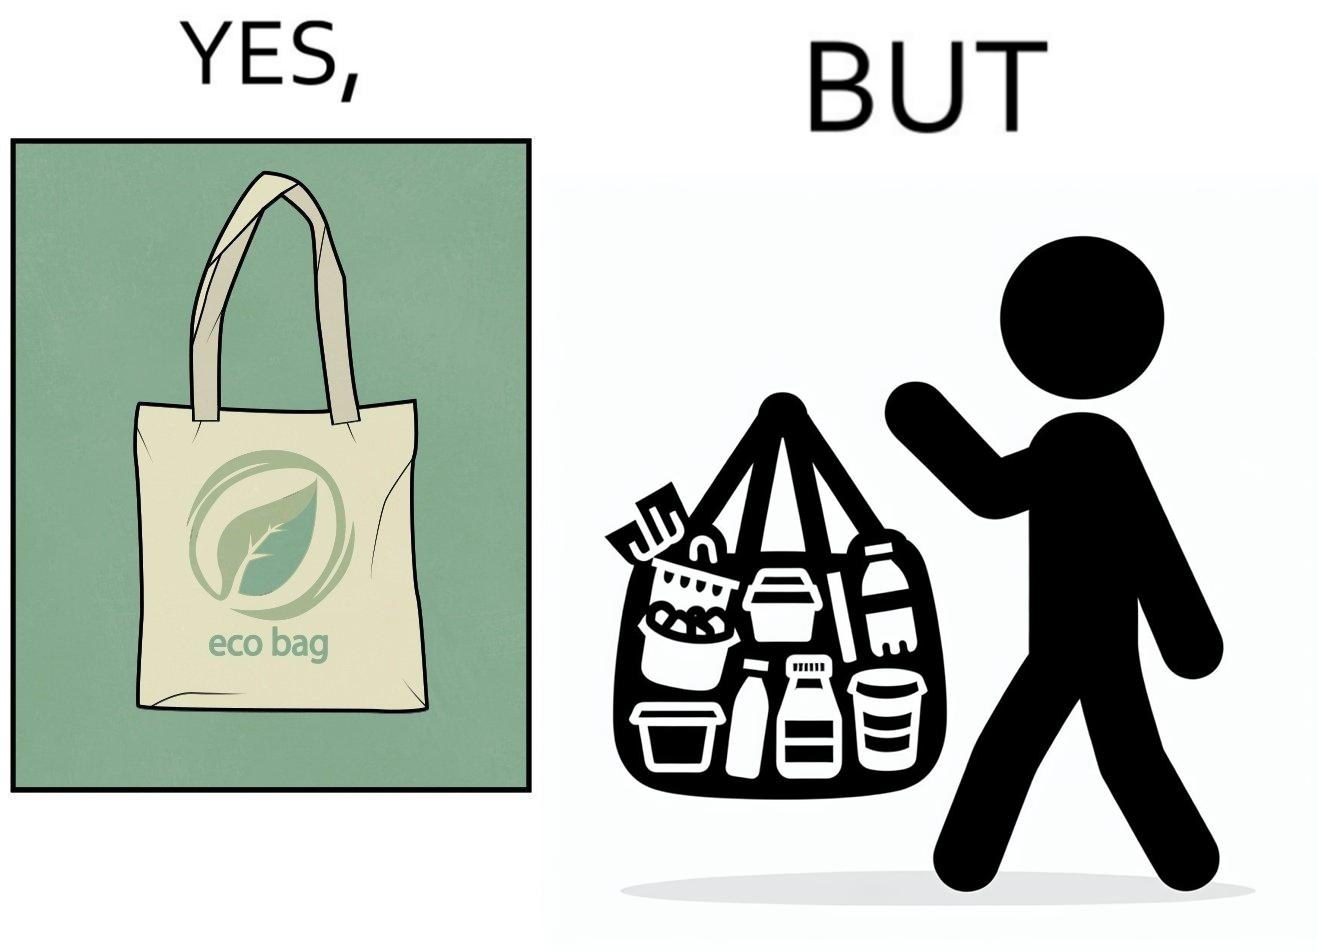Why is this image considered satirical? The image is ironic, because people nowadays use eco-bag thinking them as safe for the environment but in turn use products which are harmful for the environment or are packaged in some non-biodegradable material 